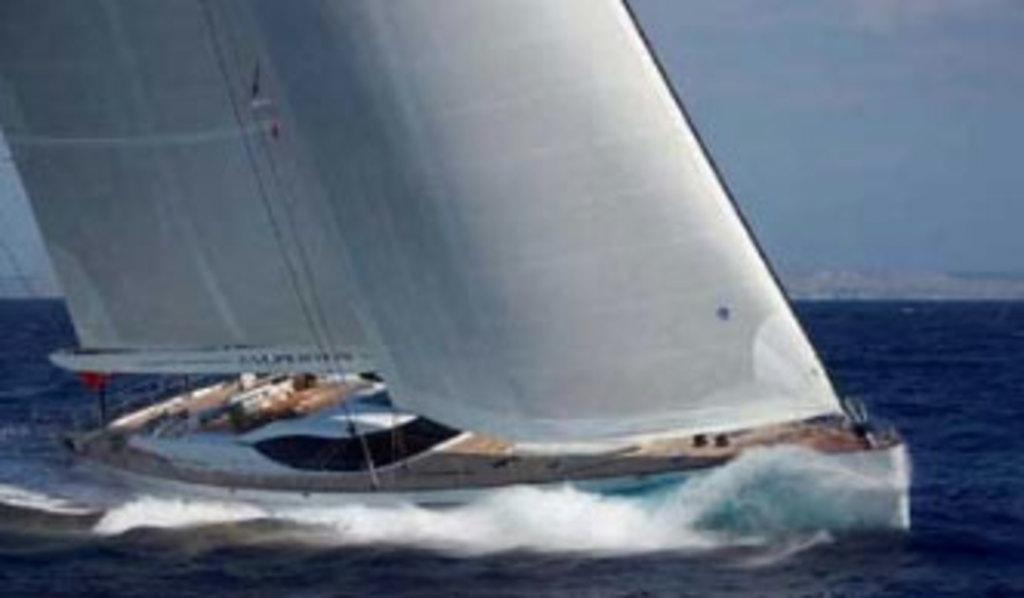What type of vehicles can be seen in the image? There are boats visible in the image. Can you describe the position of the boats in relation to the water? The boats are above the water. What is visible in the background of the image? There is a sky visible in the background of the image. What type of thought can be seen being exchanged between the boats in the image? There is no indication of any thoughts being exchanged between the boats in the image. What type of payment is being made for the boats in the image? There is no indication of any payment being made for the boats in the image. 